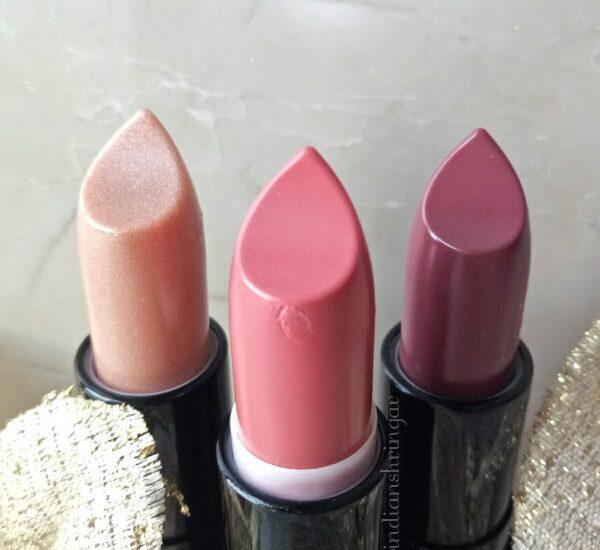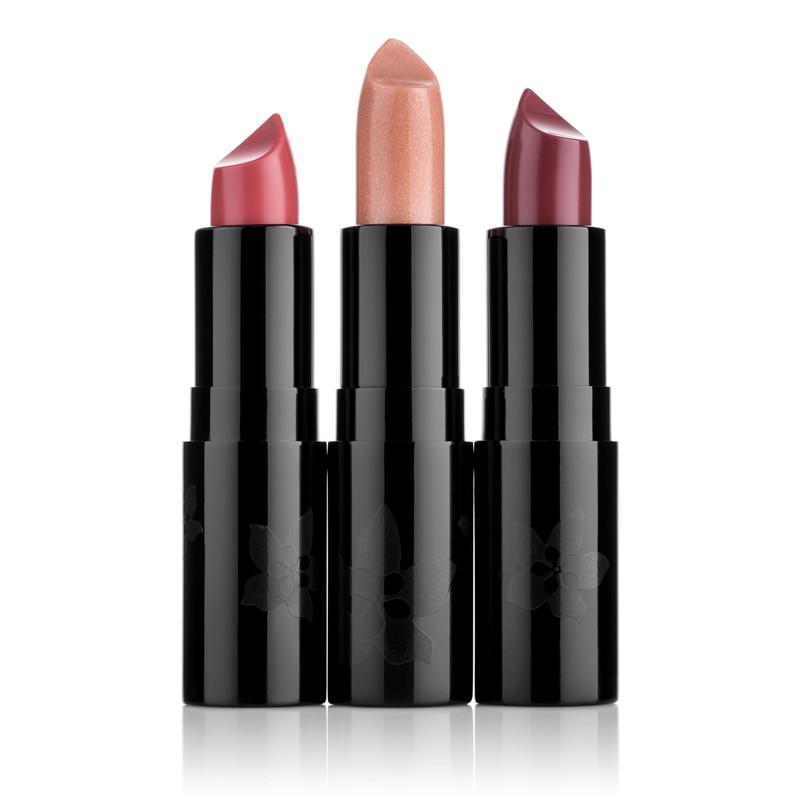The first image is the image on the left, the second image is the image on the right. Considering the images on both sides, is "The image on the right has a lipstick smudge on the left side of a single tube of lipstick." valid? Answer yes or no. No. The first image is the image on the left, the second image is the image on the right. For the images shown, is this caption "An image shows one upright tube lipstick next to its horizontal cap and a smear of color." true? Answer yes or no. No. 